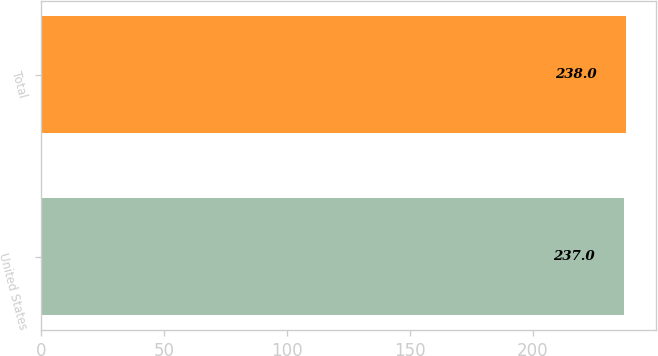Convert chart to OTSL. <chart><loc_0><loc_0><loc_500><loc_500><bar_chart><fcel>United States<fcel>Total<nl><fcel>237<fcel>238<nl></chart> 